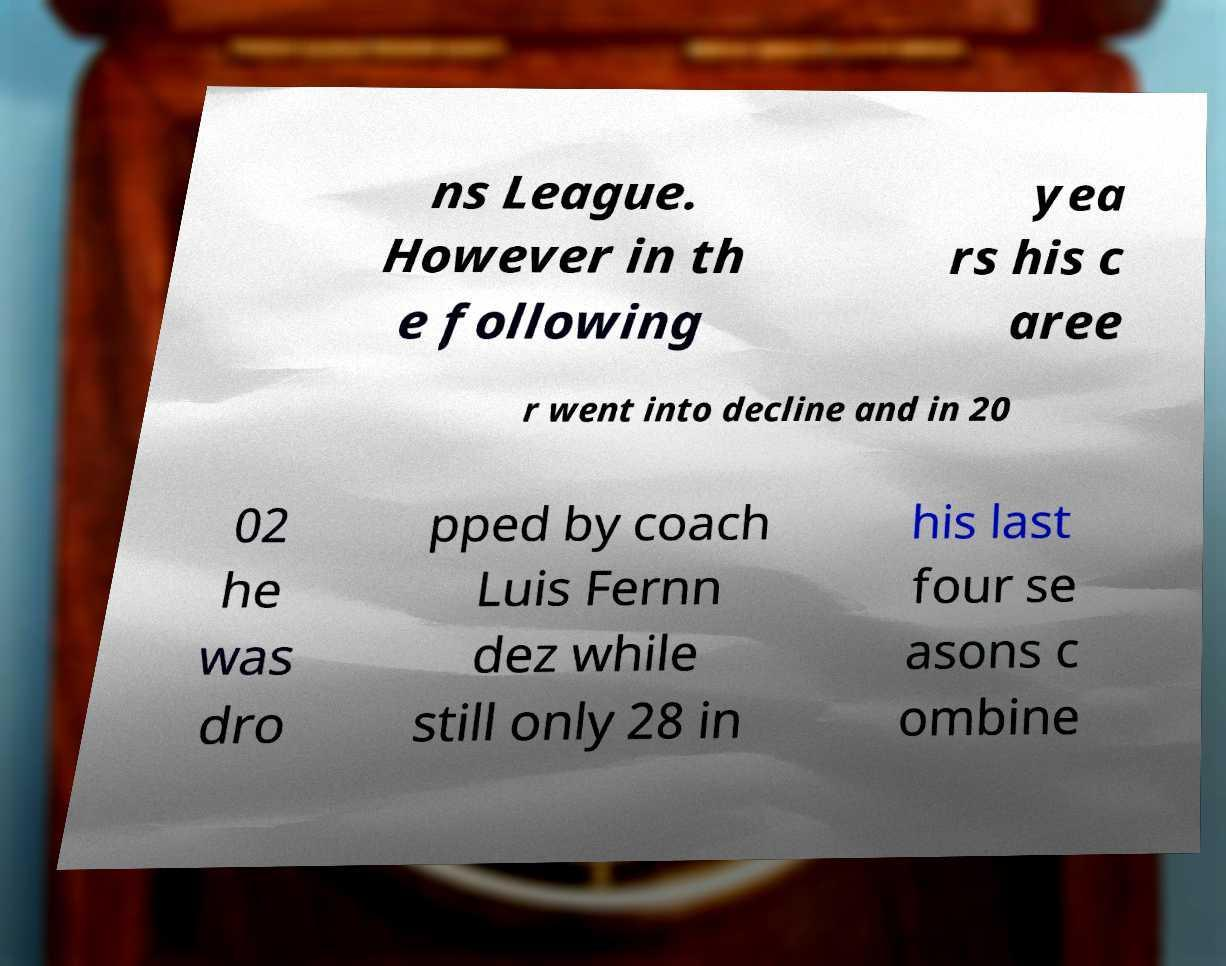For documentation purposes, I need the text within this image transcribed. Could you provide that? ns League. However in th e following yea rs his c aree r went into decline and in 20 02 he was dro pped by coach Luis Fernn dez while still only 28 in his last four se asons c ombine 